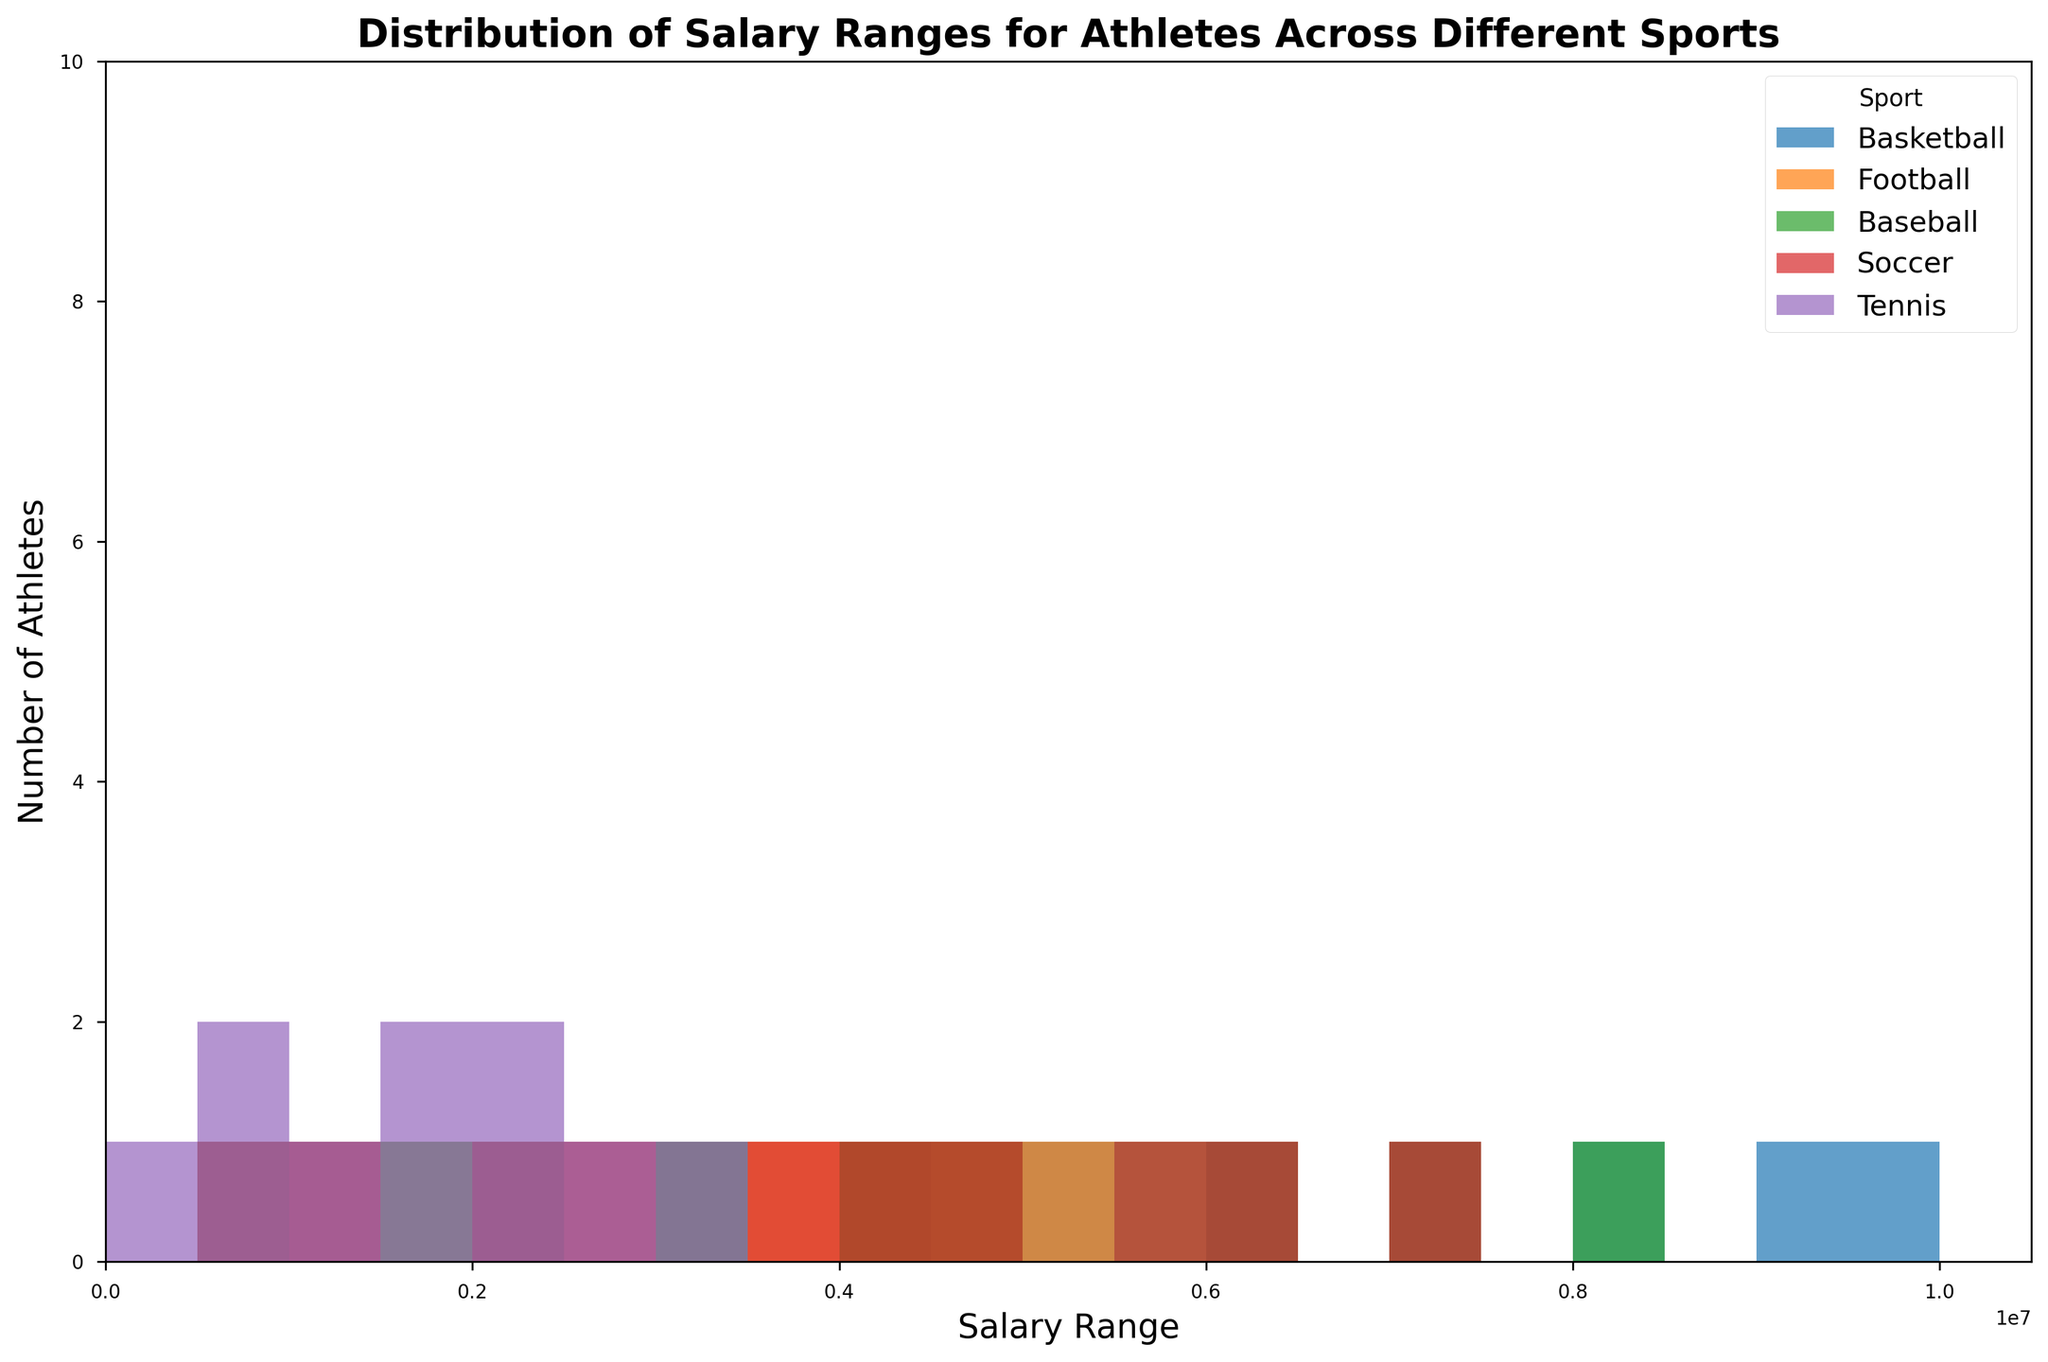What sport has the widest salary range? By looking at the histogram, basketball has salaries ranging from $1,000,000 to $10,000,000, which is a wider range compared to other sports.
Answer: Basketball Which sport has the highest number of athletes earning $3,000,000? Basketball has the tallest bar at the $3,000,000 mark, indicating the highest number of athletes in this salary range.
Answer: Basketball Is there any sport where athletes predominantly earn between $4,000,000 and $5,000,000? Both Basketball and Football show noticeable bars in this range, but Basketball has significantly more athletes earning between $4,000,000 and $5,000,000.
Answer: Basketball Which salary range has the most football players? The tallest bar for football players is seen at $3,000,000, so that is the most common salary range for them.
Answer: $3,000,000 Between baseball and soccer, which has more athletes earning above $6,000,000? Soccer has several bars above the $6,000,000 mark, whereas baseball only has bars up to $8,000,000 but fewer athletes in that range. Thus, soccer has more athletes earning above $6,000,000.
Answer: Soccer How many sports have athletes who earn $1,000,000 or less? By checking the bars at or below $1,000,000 for each sport, Tennis, Soccer, Football, and Baseball have athletes earning $1,000,000 or less.
Answer: Four sports (Tennis, Soccer, Football, and Baseball) What is the most common salary range for tennis players? The histogram shows that the tallest bar for tennis players is at the $300,000 to $600,000 salary range.
Answer: $300,000 to $600,000 Compare the number of soccer players and tennis players earning $2,000,000. The bar at $2,000,000 for soccer players is slightly taller than the bar for tennis players at the same range, indicating that more soccer players earn this amount compared to tennis players.
Answer: Soccer players Which salary range has the least representation across all sports? The histogram show that the salary range from $9,000,000 to $10,000,000 has the least representation, with only a few bars barely visible, particularly from Basketball.
Answer: $9,000,000 to $10,000,000 Compare the distribution of salaries between basketball and football players. Basketball players have a steadily increasing number of athletes up to $10,000,000, while football shows a more uniform distribution with the peak around $3,000,000. This indicates basketball players earn higher salaries on average compared to football players.
Answer: Basketball players earn more on average 